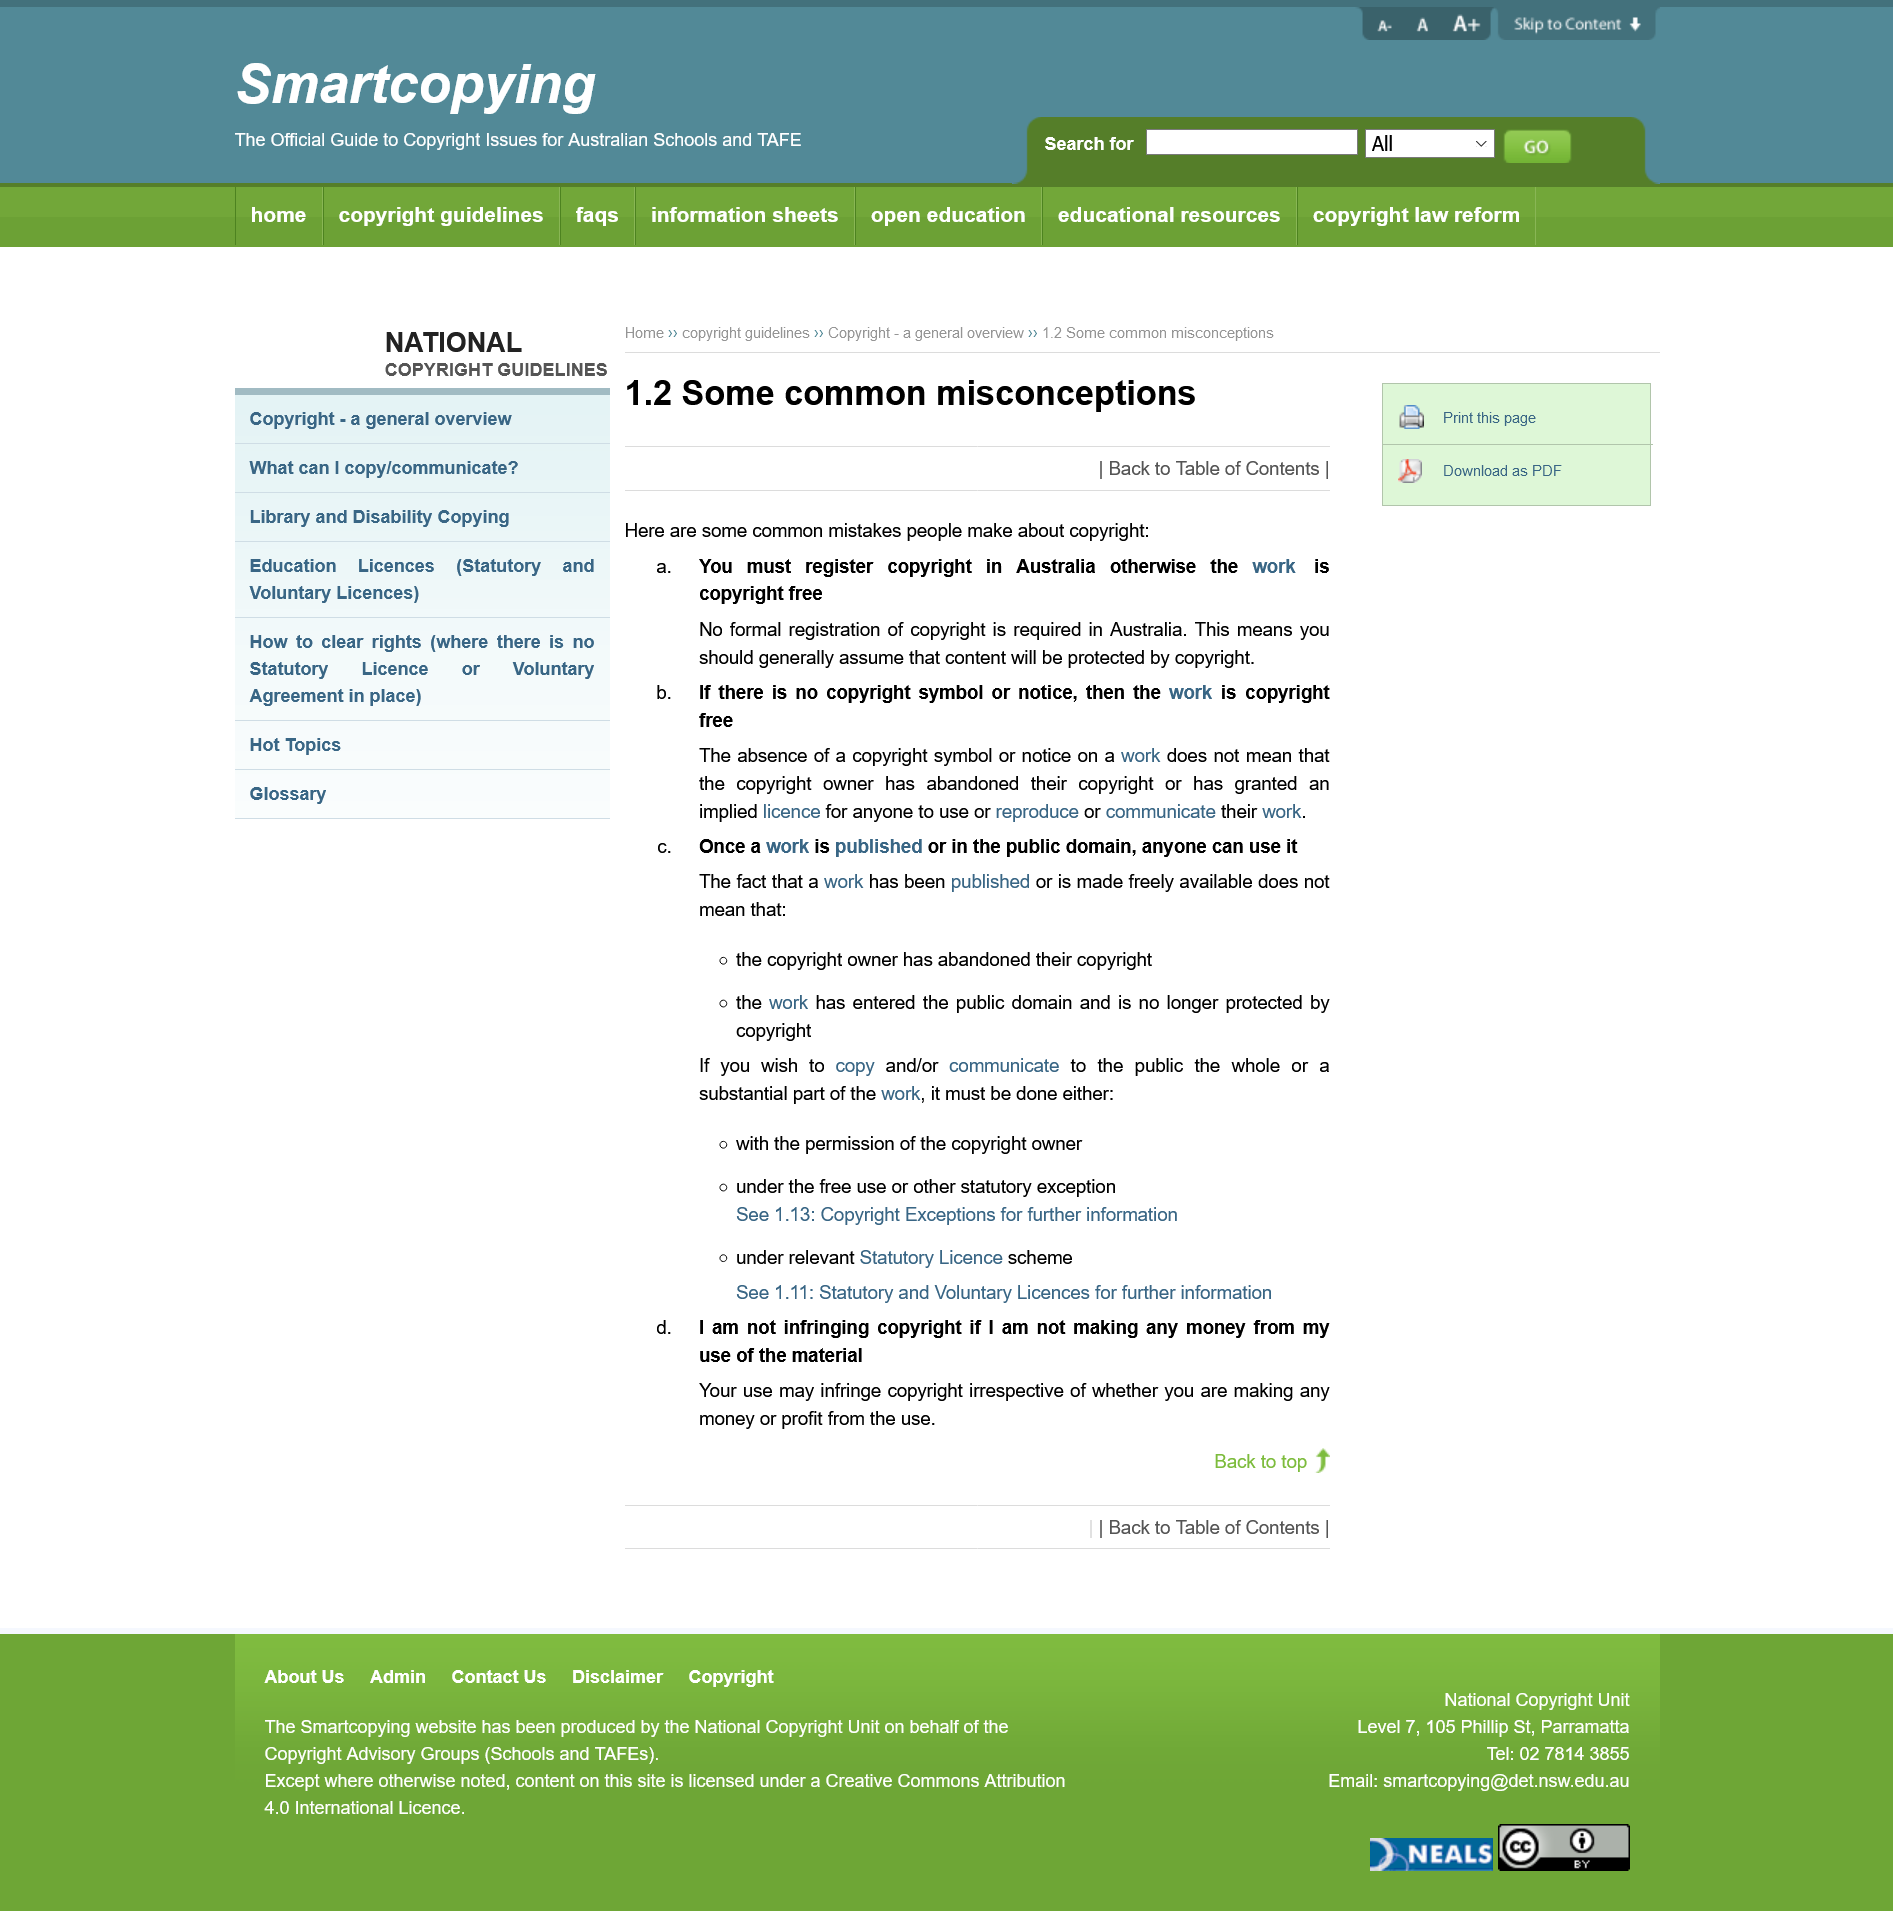Identify some key points in this picture. The fact that a work is publicly available does not mean that anyone can use it freely. The notion that copyright protection is not granted to an unregistered work or one that lacks a copyright notice is a misconception. Copyright protection subsists automatically upon creation of the work, and registration of the work with the Copyright Office is not a prerequisite for copyrightability. It is not mandatory to register copyright in Australia. 